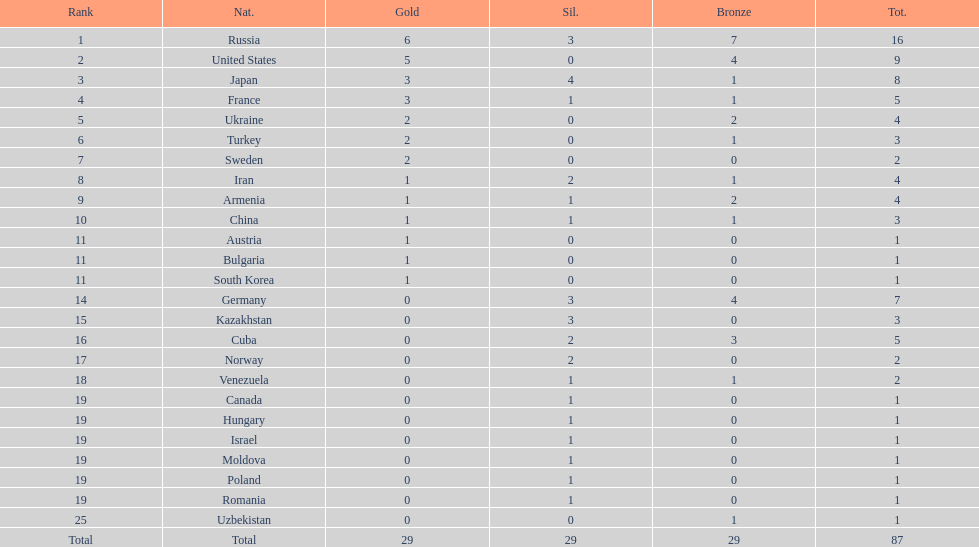Which nation has one gold medal but zero in both silver and bronze? Austria. 